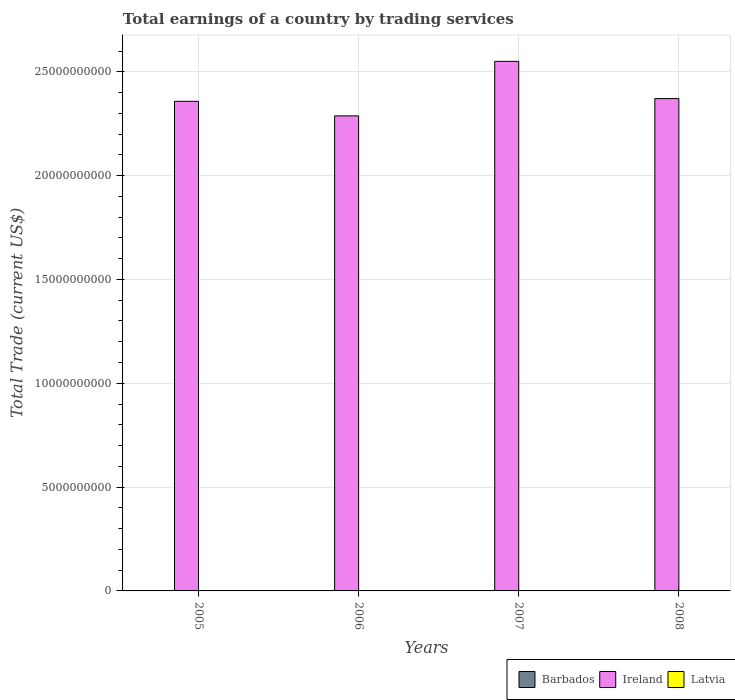How many bars are there on the 3rd tick from the left?
Keep it short and to the point. 1. How many bars are there on the 1st tick from the right?
Provide a short and direct response. 1. In how many cases, is the number of bars for a given year not equal to the number of legend labels?
Ensure brevity in your answer.  4. What is the total earnings in Barbados in 2007?
Give a very brief answer. 0. Across all years, what is the maximum total earnings in Ireland?
Offer a very short reply. 2.55e+1. What is the difference between the total earnings in Ireland in 2006 and that in 2007?
Keep it short and to the point. -2.63e+09. What is the difference between the total earnings in Ireland in 2005 and the total earnings in Latvia in 2006?
Keep it short and to the point. 2.36e+1. What is the average total earnings in Latvia per year?
Make the answer very short. 0. In how many years, is the total earnings in Barbados greater than 21000000000 US$?
Ensure brevity in your answer.  0. What is the ratio of the total earnings in Ireland in 2005 to that in 2007?
Ensure brevity in your answer.  0.92. What is the difference between the highest and the second highest total earnings in Ireland?
Give a very brief answer. 1.79e+09. What is the difference between the highest and the lowest total earnings in Ireland?
Offer a very short reply. 2.63e+09. In how many years, is the total earnings in Barbados greater than the average total earnings in Barbados taken over all years?
Offer a very short reply. 0. How many bars are there?
Ensure brevity in your answer.  4. Does the graph contain grids?
Provide a succinct answer. Yes. Where does the legend appear in the graph?
Offer a terse response. Bottom right. How many legend labels are there?
Your answer should be very brief. 3. What is the title of the graph?
Your answer should be compact. Total earnings of a country by trading services. What is the label or title of the X-axis?
Provide a succinct answer. Years. What is the label or title of the Y-axis?
Your answer should be very brief. Total Trade (current US$). What is the Total Trade (current US$) in Ireland in 2005?
Make the answer very short. 2.36e+1. What is the Total Trade (current US$) of Latvia in 2005?
Offer a terse response. 0. What is the Total Trade (current US$) in Ireland in 2006?
Give a very brief answer. 2.29e+1. What is the Total Trade (current US$) in Latvia in 2006?
Offer a terse response. 0. What is the Total Trade (current US$) in Ireland in 2007?
Give a very brief answer. 2.55e+1. What is the Total Trade (current US$) of Barbados in 2008?
Give a very brief answer. 0. What is the Total Trade (current US$) of Ireland in 2008?
Provide a short and direct response. 2.37e+1. What is the Total Trade (current US$) of Latvia in 2008?
Make the answer very short. 0. Across all years, what is the maximum Total Trade (current US$) in Ireland?
Your response must be concise. 2.55e+1. Across all years, what is the minimum Total Trade (current US$) of Ireland?
Offer a very short reply. 2.29e+1. What is the total Total Trade (current US$) in Ireland in the graph?
Give a very brief answer. 9.57e+1. What is the total Total Trade (current US$) of Latvia in the graph?
Your answer should be very brief. 0. What is the difference between the Total Trade (current US$) in Ireland in 2005 and that in 2006?
Give a very brief answer. 7.02e+08. What is the difference between the Total Trade (current US$) of Ireland in 2005 and that in 2007?
Provide a succinct answer. -1.92e+09. What is the difference between the Total Trade (current US$) in Ireland in 2005 and that in 2008?
Your response must be concise. -1.31e+08. What is the difference between the Total Trade (current US$) of Ireland in 2006 and that in 2007?
Your response must be concise. -2.63e+09. What is the difference between the Total Trade (current US$) in Ireland in 2006 and that in 2008?
Provide a short and direct response. -8.33e+08. What is the difference between the Total Trade (current US$) of Ireland in 2007 and that in 2008?
Offer a very short reply. 1.79e+09. What is the average Total Trade (current US$) in Ireland per year?
Your response must be concise. 2.39e+1. What is the ratio of the Total Trade (current US$) in Ireland in 2005 to that in 2006?
Provide a succinct answer. 1.03. What is the ratio of the Total Trade (current US$) in Ireland in 2005 to that in 2007?
Your answer should be very brief. 0.92. What is the ratio of the Total Trade (current US$) in Ireland in 2006 to that in 2007?
Provide a succinct answer. 0.9. What is the ratio of the Total Trade (current US$) of Ireland in 2006 to that in 2008?
Offer a terse response. 0.96. What is the ratio of the Total Trade (current US$) of Ireland in 2007 to that in 2008?
Provide a short and direct response. 1.08. What is the difference between the highest and the second highest Total Trade (current US$) in Ireland?
Offer a terse response. 1.79e+09. What is the difference between the highest and the lowest Total Trade (current US$) in Ireland?
Provide a succinct answer. 2.63e+09. 